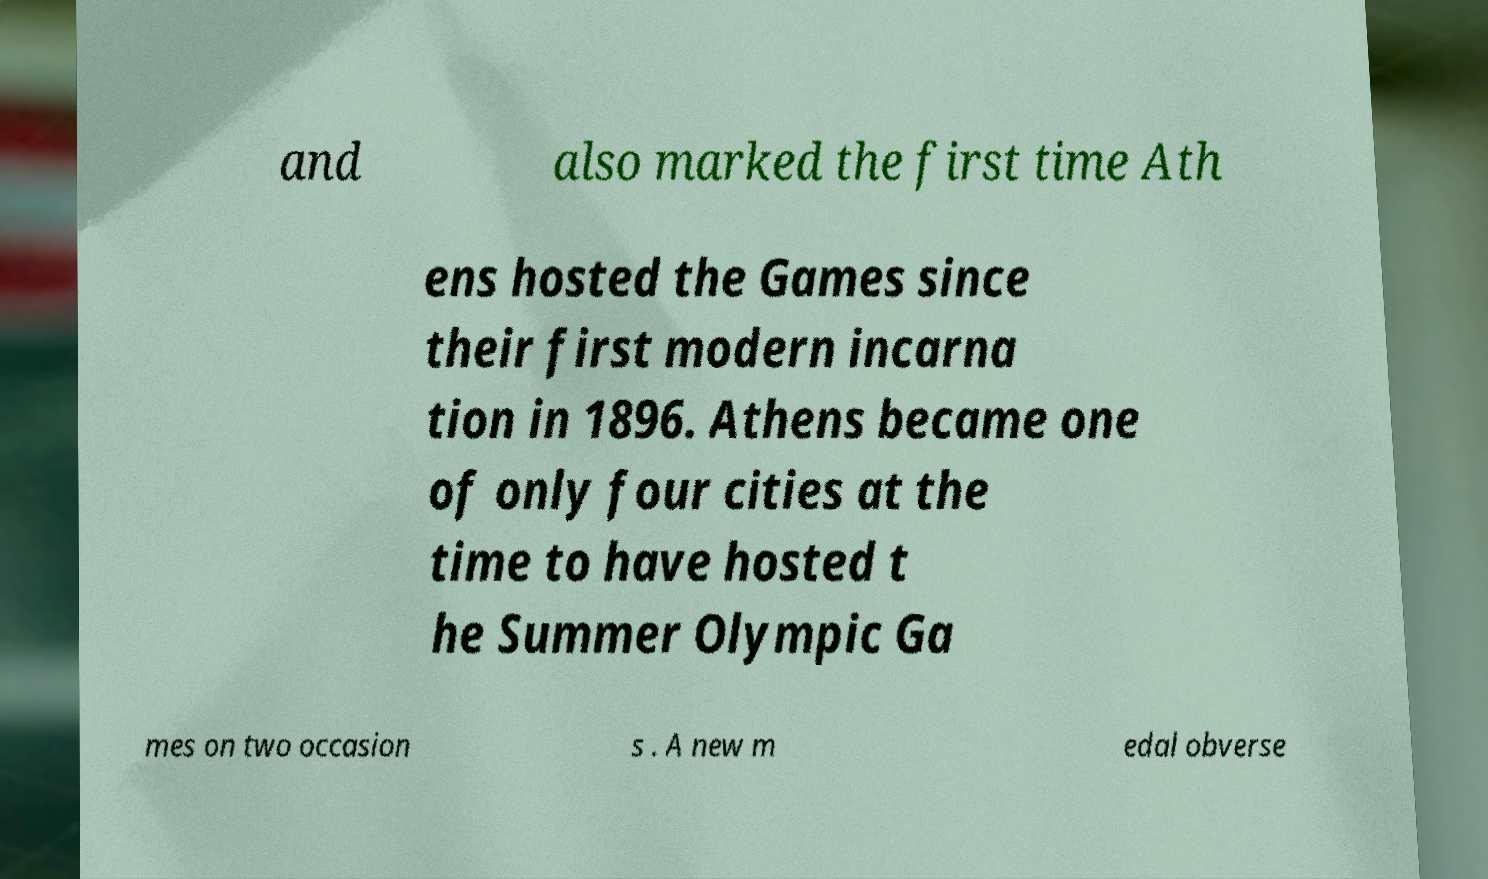Could you extract and type out the text from this image? and also marked the first time Ath ens hosted the Games since their first modern incarna tion in 1896. Athens became one of only four cities at the time to have hosted t he Summer Olympic Ga mes on two occasion s . A new m edal obverse 